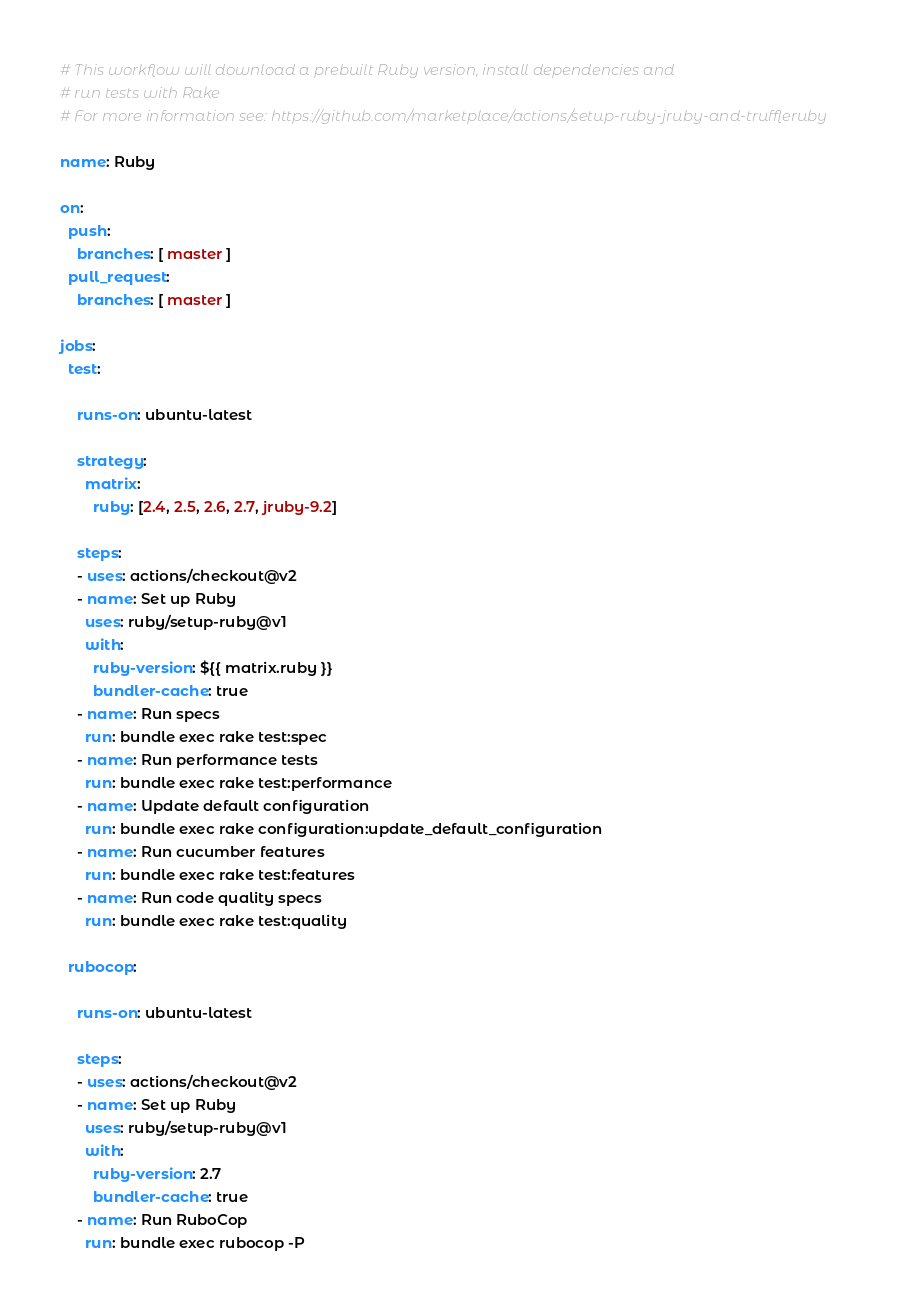<code> <loc_0><loc_0><loc_500><loc_500><_YAML_># This workflow will download a prebuilt Ruby version, install dependencies and
# run tests with Rake
# For more information see: https://github.com/marketplace/actions/setup-ruby-jruby-and-truffleruby

name: Ruby

on:
  push:
    branches: [ master ]
  pull_request:
    branches: [ master ]

jobs:
  test:

    runs-on: ubuntu-latest

    strategy:
      matrix:
        ruby: [2.4, 2.5, 2.6, 2.7, jruby-9.2]

    steps:
    - uses: actions/checkout@v2
    - name: Set up Ruby
      uses: ruby/setup-ruby@v1
      with:
        ruby-version: ${{ matrix.ruby }}
        bundler-cache: true
    - name: Run specs
      run: bundle exec rake test:spec
    - name: Run performance tests
      run: bundle exec rake test:performance
    - name: Update default configuration
      run: bundle exec rake configuration:update_default_configuration
    - name: Run cucumber features
      run: bundle exec rake test:features
    - name: Run code quality specs
      run: bundle exec rake test:quality

  rubocop:

    runs-on: ubuntu-latest

    steps:
    - uses: actions/checkout@v2
    - name: Set up Ruby
      uses: ruby/setup-ruby@v1
      with:
        ruby-version: 2.7
        bundler-cache: true
    - name: Run RuboCop
      run: bundle exec rubocop -P
</code> 